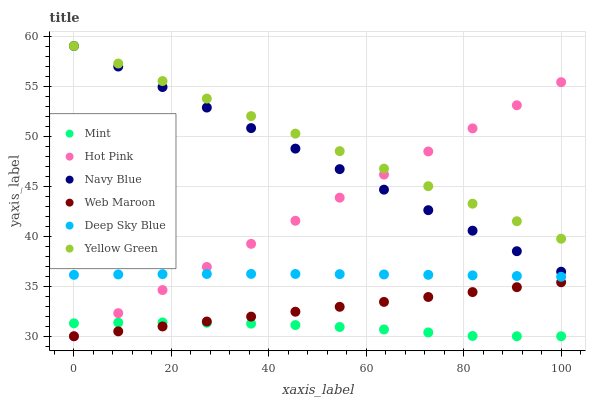Does Mint have the minimum area under the curve?
Answer yes or no. Yes. Does Yellow Green have the maximum area under the curve?
Answer yes or no. Yes. Does Navy Blue have the minimum area under the curve?
Answer yes or no. No. Does Navy Blue have the maximum area under the curve?
Answer yes or no. No. Is Navy Blue the smoothest?
Answer yes or no. Yes. Is Mint the roughest?
Answer yes or no. Yes. Is Hot Pink the smoothest?
Answer yes or no. No. Is Hot Pink the roughest?
Answer yes or no. No. Does Hot Pink have the lowest value?
Answer yes or no. Yes. Does Navy Blue have the lowest value?
Answer yes or no. No. Does Navy Blue have the highest value?
Answer yes or no. Yes. Does Hot Pink have the highest value?
Answer yes or no. No. Is Mint less than Navy Blue?
Answer yes or no. Yes. Is Navy Blue greater than Mint?
Answer yes or no. Yes. Does Yellow Green intersect Navy Blue?
Answer yes or no. Yes. Is Yellow Green less than Navy Blue?
Answer yes or no. No. Is Yellow Green greater than Navy Blue?
Answer yes or no. No. Does Mint intersect Navy Blue?
Answer yes or no. No. 